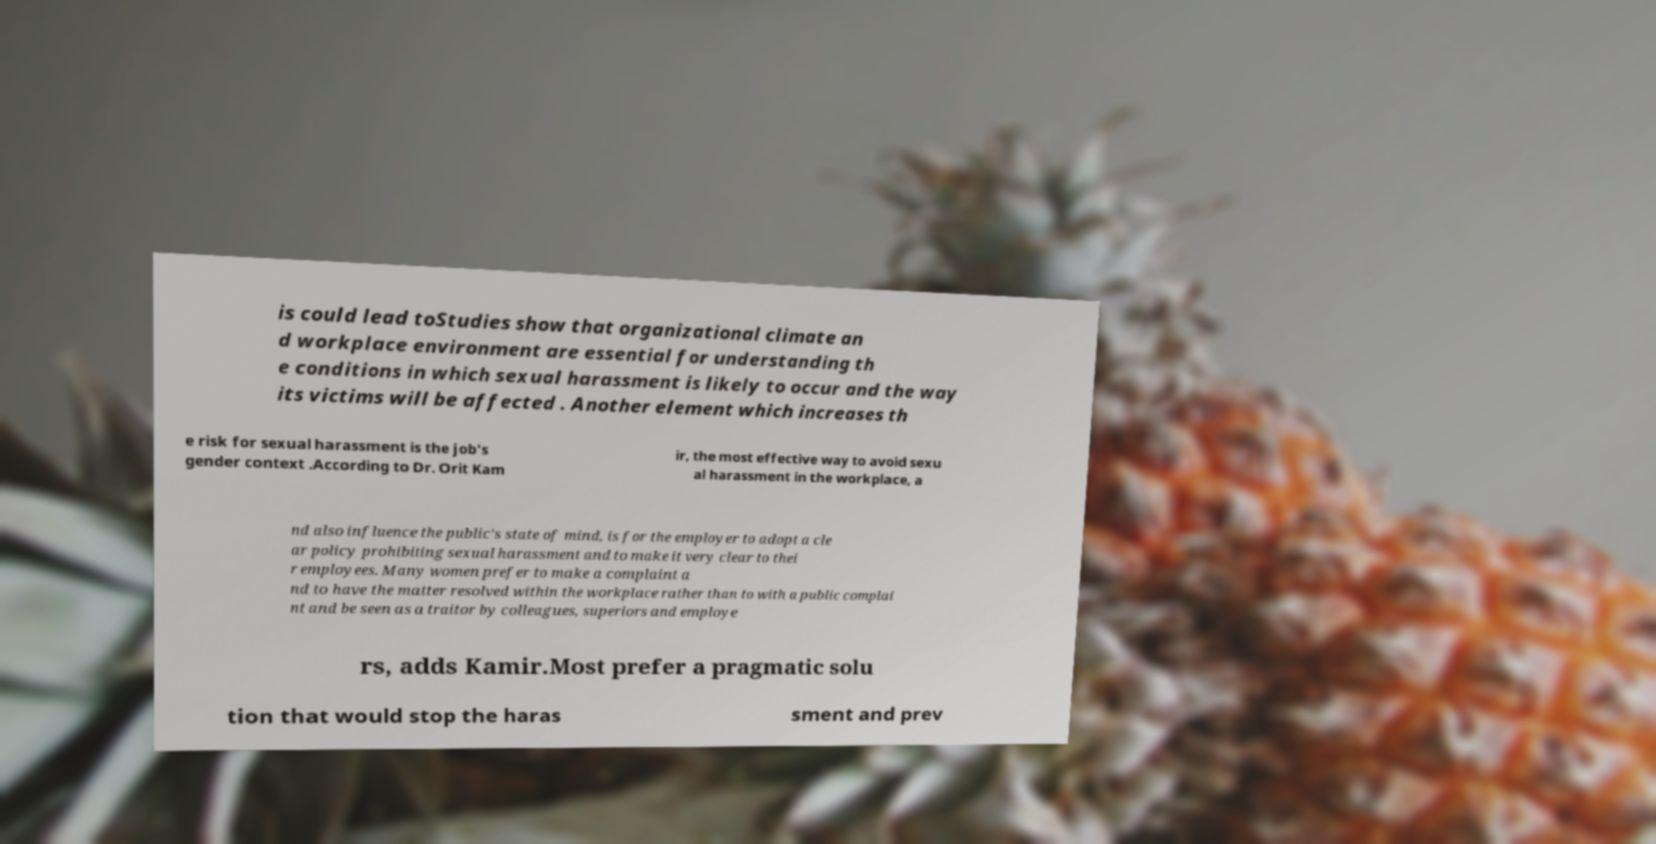Can you accurately transcribe the text from the provided image for me? is could lead toStudies show that organizational climate an d workplace environment are essential for understanding th e conditions in which sexual harassment is likely to occur and the way its victims will be affected . Another element which increases th e risk for sexual harassment is the job's gender context .According to Dr. Orit Kam ir, the most effective way to avoid sexu al harassment in the workplace, a nd also influence the public's state of mind, is for the employer to adopt a cle ar policy prohibiting sexual harassment and to make it very clear to thei r employees. Many women prefer to make a complaint a nd to have the matter resolved within the workplace rather than to with a public complai nt and be seen as a traitor by colleagues, superiors and employe rs, adds Kamir.Most prefer a pragmatic solu tion that would stop the haras sment and prev 